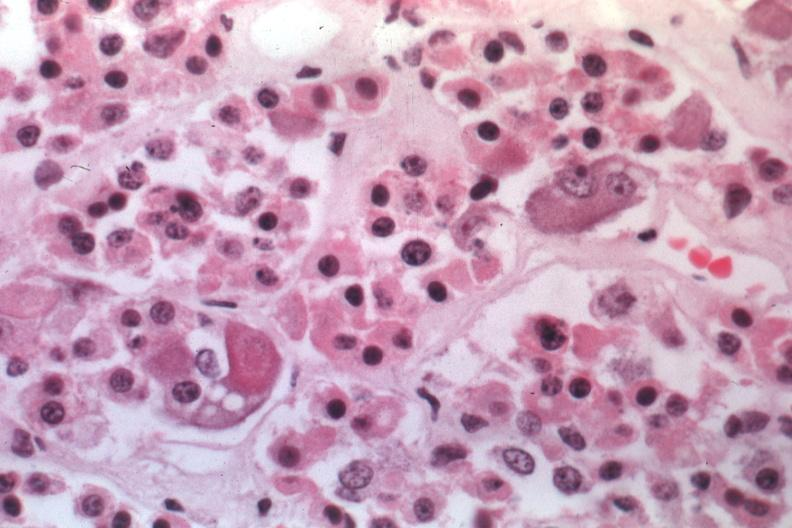s endocrine present?
Answer the question using a single word or phrase. Yes 